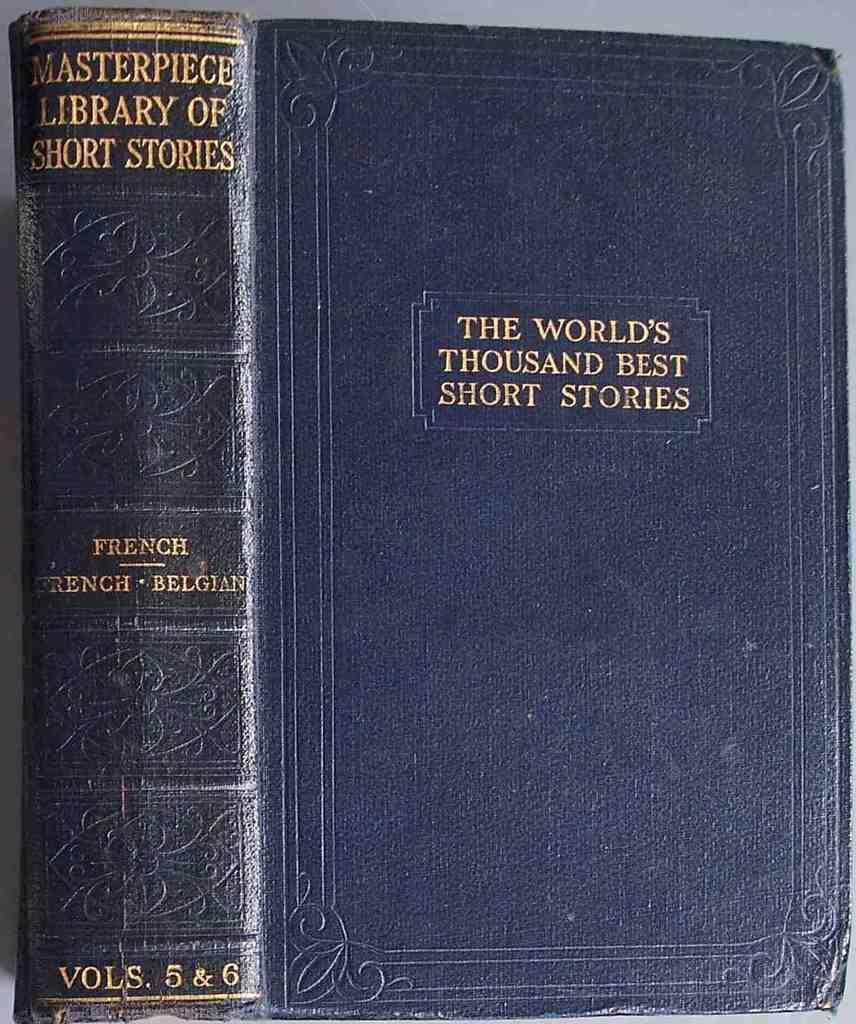<image>
Summarize the visual content of the image. Vols. 5 & 6 of The World's Thousand Best Short Stories collection has a blue cover. 